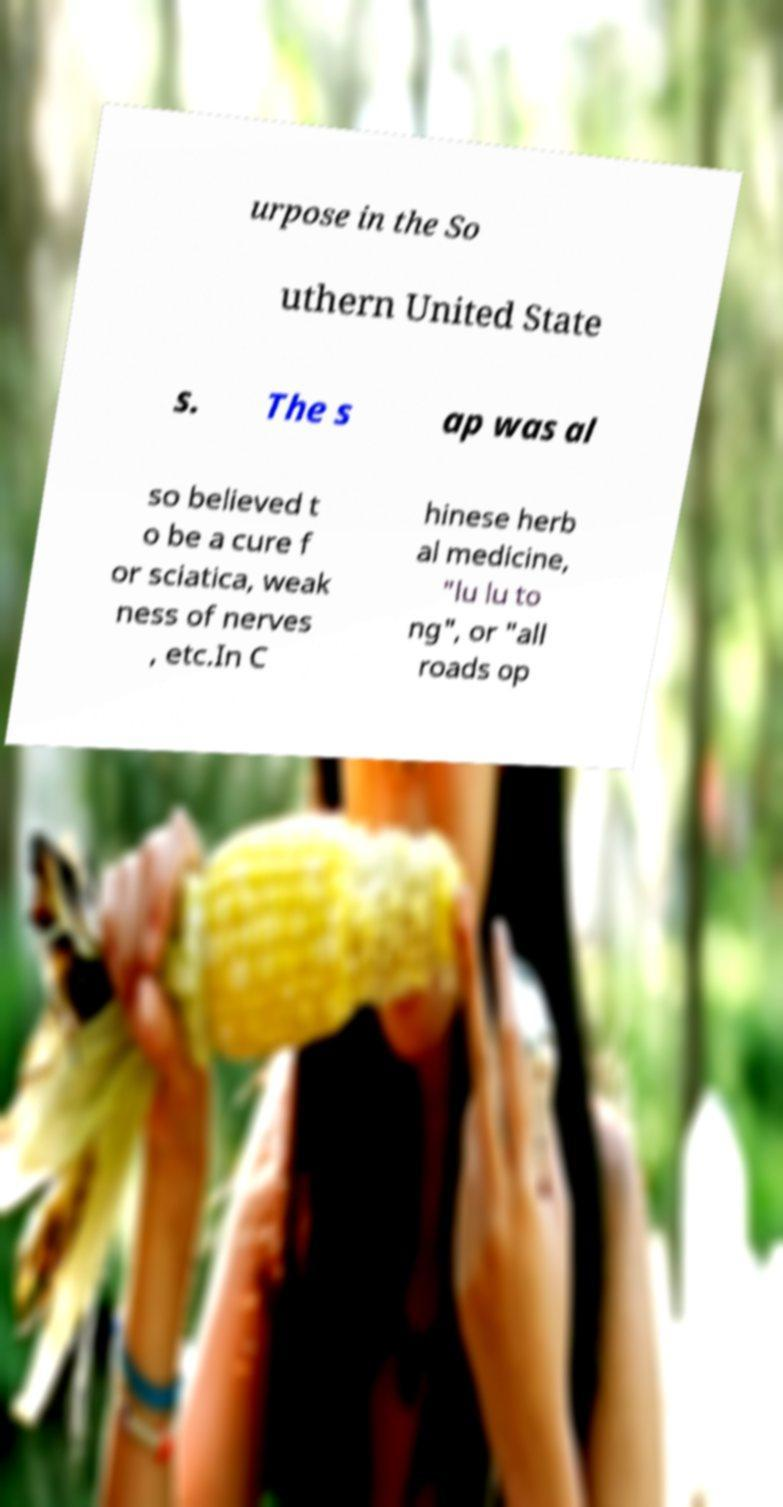I need the written content from this picture converted into text. Can you do that? urpose in the So uthern United State s. The s ap was al so believed t o be a cure f or sciatica, weak ness of nerves , etc.In C hinese herb al medicine, "lu lu to ng", or "all roads op 